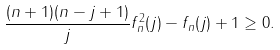Convert formula to latex. <formula><loc_0><loc_0><loc_500><loc_500>\frac { ( n + 1 ) ( n - j + 1 ) } { j } f _ { n } ^ { 2 } ( j ) - f _ { n } ( j ) + 1 \geq 0 .</formula> 